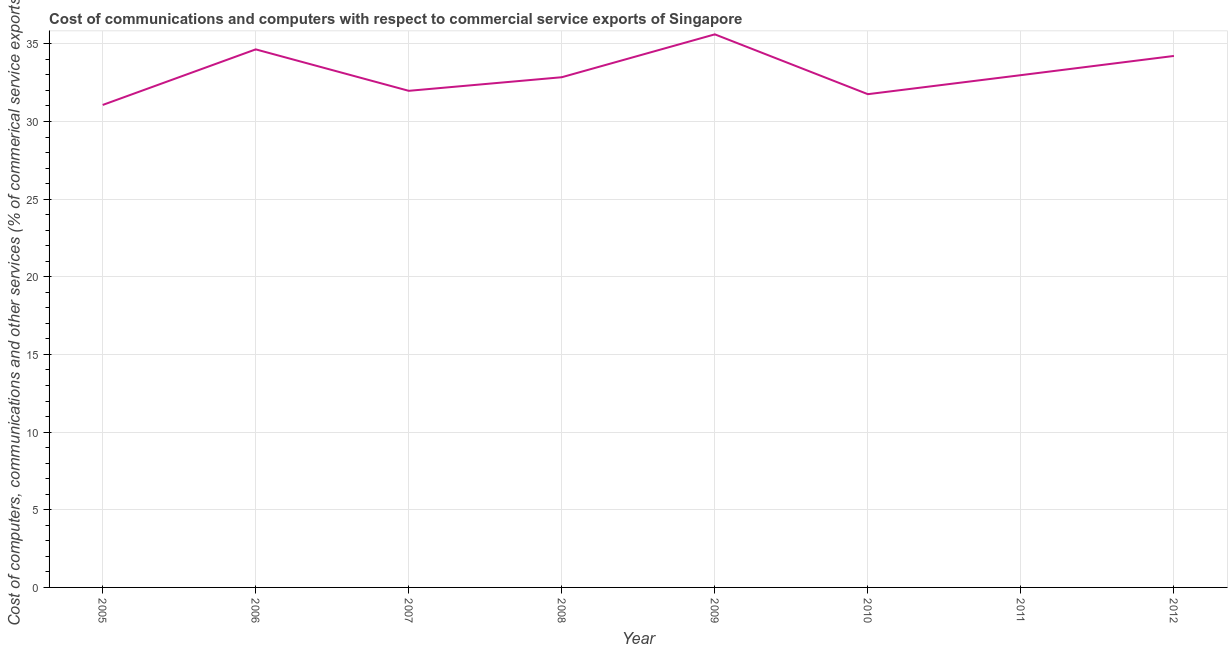What is the  computer and other services in 2007?
Provide a succinct answer. 31.98. Across all years, what is the maximum  computer and other services?
Your answer should be very brief. 35.61. Across all years, what is the minimum cost of communications?
Your answer should be compact. 31.07. In which year was the  computer and other services maximum?
Give a very brief answer. 2009. What is the sum of the  computer and other services?
Your response must be concise. 265.11. What is the difference between the cost of communications in 2008 and 2012?
Offer a very short reply. -1.37. What is the average cost of communications per year?
Give a very brief answer. 33.14. What is the median cost of communications?
Provide a short and direct response. 32.92. In how many years, is the cost of communications greater than 17 %?
Offer a very short reply. 8. What is the ratio of the  computer and other services in 2006 to that in 2007?
Provide a succinct answer. 1.08. What is the difference between the highest and the second highest  computer and other services?
Provide a short and direct response. 0.97. What is the difference between the highest and the lowest cost of communications?
Ensure brevity in your answer.  4.55. In how many years, is the cost of communications greater than the average cost of communications taken over all years?
Offer a very short reply. 3. Does the  computer and other services monotonically increase over the years?
Offer a terse response. No. How many lines are there?
Offer a very short reply. 1. Does the graph contain any zero values?
Give a very brief answer. No. What is the title of the graph?
Provide a short and direct response. Cost of communications and computers with respect to commercial service exports of Singapore. What is the label or title of the X-axis?
Keep it short and to the point. Year. What is the label or title of the Y-axis?
Provide a succinct answer. Cost of computers, communications and other services (% of commerical service exports). What is the Cost of computers, communications and other services (% of commerical service exports) of 2005?
Your answer should be very brief. 31.07. What is the Cost of computers, communications and other services (% of commerical service exports) in 2006?
Your answer should be very brief. 34.64. What is the Cost of computers, communications and other services (% of commerical service exports) of 2007?
Make the answer very short. 31.98. What is the Cost of computers, communications and other services (% of commerical service exports) of 2008?
Your answer should be very brief. 32.85. What is the Cost of computers, communications and other services (% of commerical service exports) of 2009?
Offer a very short reply. 35.61. What is the Cost of computers, communications and other services (% of commerical service exports) in 2010?
Provide a succinct answer. 31.76. What is the Cost of computers, communications and other services (% of commerical service exports) of 2011?
Provide a succinct answer. 32.98. What is the Cost of computers, communications and other services (% of commerical service exports) in 2012?
Provide a succinct answer. 34.22. What is the difference between the Cost of computers, communications and other services (% of commerical service exports) in 2005 and 2006?
Offer a terse response. -3.58. What is the difference between the Cost of computers, communications and other services (% of commerical service exports) in 2005 and 2007?
Offer a terse response. -0.91. What is the difference between the Cost of computers, communications and other services (% of commerical service exports) in 2005 and 2008?
Provide a succinct answer. -1.79. What is the difference between the Cost of computers, communications and other services (% of commerical service exports) in 2005 and 2009?
Provide a short and direct response. -4.55. What is the difference between the Cost of computers, communications and other services (% of commerical service exports) in 2005 and 2010?
Make the answer very short. -0.69. What is the difference between the Cost of computers, communications and other services (% of commerical service exports) in 2005 and 2011?
Offer a terse response. -1.92. What is the difference between the Cost of computers, communications and other services (% of commerical service exports) in 2005 and 2012?
Provide a short and direct response. -3.16. What is the difference between the Cost of computers, communications and other services (% of commerical service exports) in 2006 and 2007?
Offer a terse response. 2.67. What is the difference between the Cost of computers, communications and other services (% of commerical service exports) in 2006 and 2008?
Offer a terse response. 1.79. What is the difference between the Cost of computers, communications and other services (% of commerical service exports) in 2006 and 2009?
Provide a succinct answer. -0.97. What is the difference between the Cost of computers, communications and other services (% of commerical service exports) in 2006 and 2010?
Your answer should be compact. 2.89. What is the difference between the Cost of computers, communications and other services (% of commerical service exports) in 2006 and 2011?
Provide a succinct answer. 1.66. What is the difference between the Cost of computers, communications and other services (% of commerical service exports) in 2006 and 2012?
Your answer should be very brief. 0.42. What is the difference between the Cost of computers, communications and other services (% of commerical service exports) in 2007 and 2008?
Provide a succinct answer. -0.88. What is the difference between the Cost of computers, communications and other services (% of commerical service exports) in 2007 and 2009?
Your answer should be compact. -3.64. What is the difference between the Cost of computers, communications and other services (% of commerical service exports) in 2007 and 2010?
Your answer should be very brief. 0.22. What is the difference between the Cost of computers, communications and other services (% of commerical service exports) in 2007 and 2011?
Give a very brief answer. -1.01. What is the difference between the Cost of computers, communications and other services (% of commerical service exports) in 2007 and 2012?
Provide a succinct answer. -2.25. What is the difference between the Cost of computers, communications and other services (% of commerical service exports) in 2008 and 2009?
Provide a short and direct response. -2.76. What is the difference between the Cost of computers, communications and other services (% of commerical service exports) in 2008 and 2010?
Provide a short and direct response. 1.09. What is the difference between the Cost of computers, communications and other services (% of commerical service exports) in 2008 and 2011?
Provide a succinct answer. -0.13. What is the difference between the Cost of computers, communications and other services (% of commerical service exports) in 2008 and 2012?
Give a very brief answer. -1.37. What is the difference between the Cost of computers, communications and other services (% of commerical service exports) in 2009 and 2010?
Give a very brief answer. 3.85. What is the difference between the Cost of computers, communications and other services (% of commerical service exports) in 2009 and 2011?
Keep it short and to the point. 2.63. What is the difference between the Cost of computers, communications and other services (% of commerical service exports) in 2009 and 2012?
Make the answer very short. 1.39. What is the difference between the Cost of computers, communications and other services (% of commerical service exports) in 2010 and 2011?
Give a very brief answer. -1.22. What is the difference between the Cost of computers, communications and other services (% of commerical service exports) in 2010 and 2012?
Your answer should be compact. -2.46. What is the difference between the Cost of computers, communications and other services (% of commerical service exports) in 2011 and 2012?
Offer a very short reply. -1.24. What is the ratio of the Cost of computers, communications and other services (% of commerical service exports) in 2005 to that in 2006?
Keep it short and to the point. 0.9. What is the ratio of the Cost of computers, communications and other services (% of commerical service exports) in 2005 to that in 2007?
Your response must be concise. 0.97. What is the ratio of the Cost of computers, communications and other services (% of commerical service exports) in 2005 to that in 2008?
Ensure brevity in your answer.  0.95. What is the ratio of the Cost of computers, communications and other services (% of commerical service exports) in 2005 to that in 2009?
Make the answer very short. 0.87. What is the ratio of the Cost of computers, communications and other services (% of commerical service exports) in 2005 to that in 2011?
Provide a short and direct response. 0.94. What is the ratio of the Cost of computers, communications and other services (% of commerical service exports) in 2005 to that in 2012?
Give a very brief answer. 0.91. What is the ratio of the Cost of computers, communications and other services (% of commerical service exports) in 2006 to that in 2007?
Your answer should be compact. 1.08. What is the ratio of the Cost of computers, communications and other services (% of commerical service exports) in 2006 to that in 2008?
Offer a very short reply. 1.05. What is the ratio of the Cost of computers, communications and other services (% of commerical service exports) in 2006 to that in 2010?
Keep it short and to the point. 1.09. What is the ratio of the Cost of computers, communications and other services (% of commerical service exports) in 2006 to that in 2011?
Give a very brief answer. 1.05. What is the ratio of the Cost of computers, communications and other services (% of commerical service exports) in 2006 to that in 2012?
Give a very brief answer. 1.01. What is the ratio of the Cost of computers, communications and other services (% of commerical service exports) in 2007 to that in 2008?
Provide a succinct answer. 0.97. What is the ratio of the Cost of computers, communications and other services (% of commerical service exports) in 2007 to that in 2009?
Provide a short and direct response. 0.9. What is the ratio of the Cost of computers, communications and other services (% of commerical service exports) in 2007 to that in 2010?
Provide a short and direct response. 1.01. What is the ratio of the Cost of computers, communications and other services (% of commerical service exports) in 2007 to that in 2012?
Offer a terse response. 0.93. What is the ratio of the Cost of computers, communications and other services (% of commerical service exports) in 2008 to that in 2009?
Give a very brief answer. 0.92. What is the ratio of the Cost of computers, communications and other services (% of commerical service exports) in 2008 to that in 2010?
Ensure brevity in your answer.  1.03. What is the ratio of the Cost of computers, communications and other services (% of commerical service exports) in 2008 to that in 2012?
Your answer should be compact. 0.96. What is the ratio of the Cost of computers, communications and other services (% of commerical service exports) in 2009 to that in 2010?
Offer a terse response. 1.12. What is the ratio of the Cost of computers, communications and other services (% of commerical service exports) in 2009 to that in 2012?
Your answer should be compact. 1.04. What is the ratio of the Cost of computers, communications and other services (% of commerical service exports) in 2010 to that in 2012?
Provide a short and direct response. 0.93. 